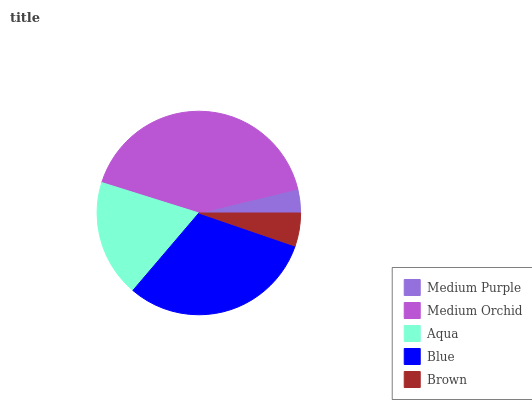Is Medium Purple the minimum?
Answer yes or no. Yes. Is Medium Orchid the maximum?
Answer yes or no. Yes. Is Aqua the minimum?
Answer yes or no. No. Is Aqua the maximum?
Answer yes or no. No. Is Medium Orchid greater than Aqua?
Answer yes or no. Yes. Is Aqua less than Medium Orchid?
Answer yes or no. Yes. Is Aqua greater than Medium Orchid?
Answer yes or no. No. Is Medium Orchid less than Aqua?
Answer yes or no. No. Is Aqua the high median?
Answer yes or no. Yes. Is Aqua the low median?
Answer yes or no. Yes. Is Medium Purple the high median?
Answer yes or no. No. Is Medium Purple the low median?
Answer yes or no. No. 